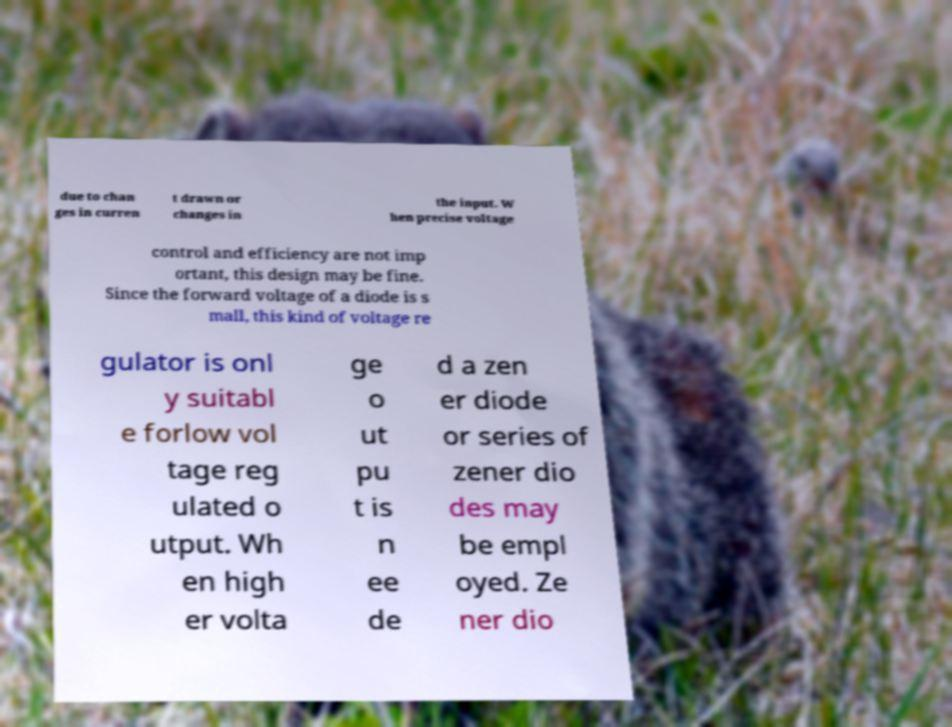What messages or text are displayed in this image? I need them in a readable, typed format. due to chan ges in curren t drawn or changes in the input. W hen precise voltage control and efficiency are not imp ortant, this design may be fine. Since the forward voltage of a diode is s mall, this kind of voltage re gulator is onl y suitabl e forlow vol tage reg ulated o utput. Wh en high er volta ge o ut pu t is n ee de d a zen er diode or series of zener dio des may be empl oyed. Ze ner dio 